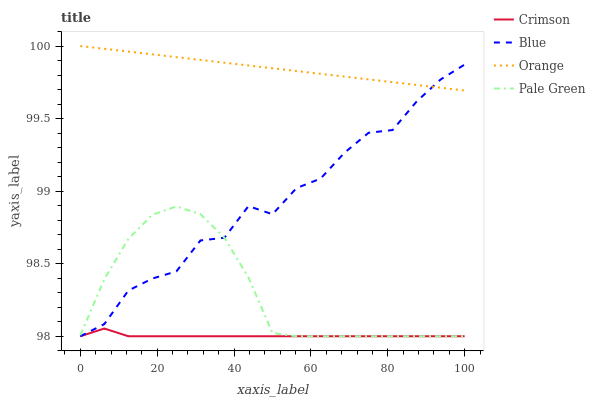Does Crimson have the minimum area under the curve?
Answer yes or no. Yes. Does Orange have the maximum area under the curve?
Answer yes or no. Yes. Does Blue have the minimum area under the curve?
Answer yes or no. No. Does Blue have the maximum area under the curve?
Answer yes or no. No. Is Orange the smoothest?
Answer yes or no. Yes. Is Blue the roughest?
Answer yes or no. Yes. Is Blue the smoothest?
Answer yes or no. No. Is Orange the roughest?
Answer yes or no. No. Does Orange have the lowest value?
Answer yes or no. No. Does Orange have the highest value?
Answer yes or no. Yes. Does Blue have the highest value?
Answer yes or no. No. Is Pale Green less than Orange?
Answer yes or no. Yes. Is Orange greater than Crimson?
Answer yes or no. Yes. Does Pale Green intersect Orange?
Answer yes or no. No. 